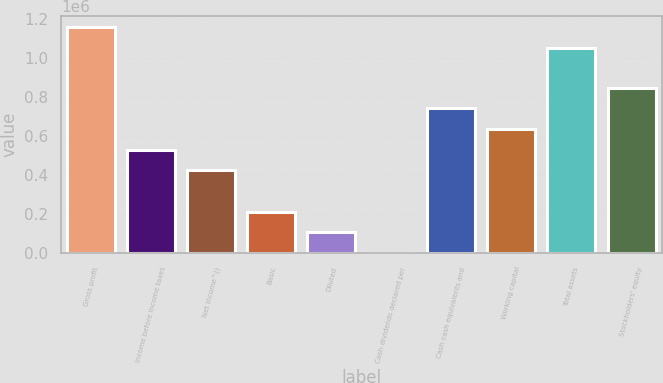Convert chart to OTSL. <chart><loc_0><loc_0><loc_500><loc_500><bar_chart><fcel>Gross profit<fcel>Income before income taxes<fcel>Net income^()<fcel>Basic<fcel>Diluted<fcel>Cash dividends declared per<fcel>Cash cash equivalents and<fcel>Working capital<fcel>Total assets<fcel>Stockholders' equity<nl><fcel>1.15766e+06<fcel>530250<fcel>424200<fcel>212100<fcel>106050<fcel>0.05<fcel>742350<fcel>636300<fcel>1.05161e+06<fcel>848400<nl></chart> 